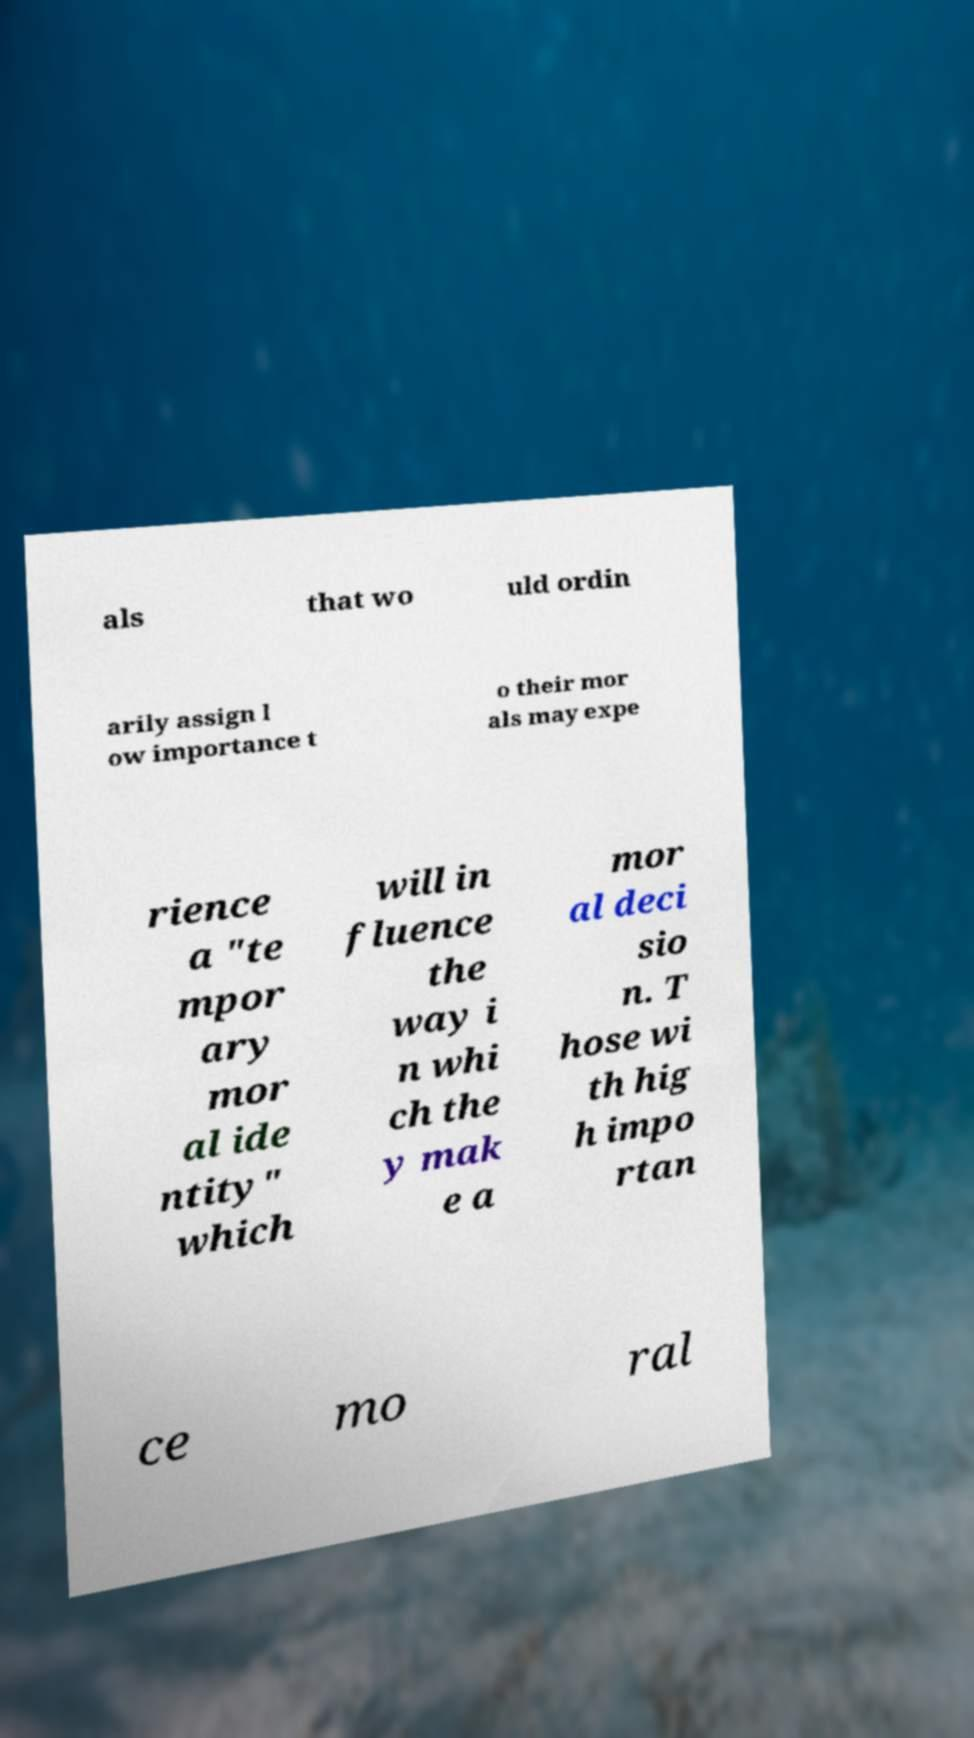Could you assist in decoding the text presented in this image and type it out clearly? als that wo uld ordin arily assign l ow importance t o their mor als may expe rience a "te mpor ary mor al ide ntity" which will in fluence the way i n whi ch the y mak e a mor al deci sio n. T hose wi th hig h impo rtan ce mo ral 